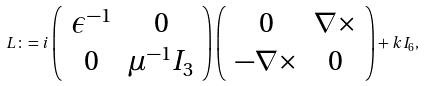<formula> <loc_0><loc_0><loc_500><loc_500>L \colon = i \left ( \begin{array} { c c } \epsilon ^ { - 1 } & 0 \\ 0 & \mu ^ { - 1 } I _ { 3 } \end{array} \right ) \left ( \begin{array} { c c } 0 & \nabla \times \\ - \nabla \times & 0 \end{array} \right ) + k I _ { 6 } ,</formula> 